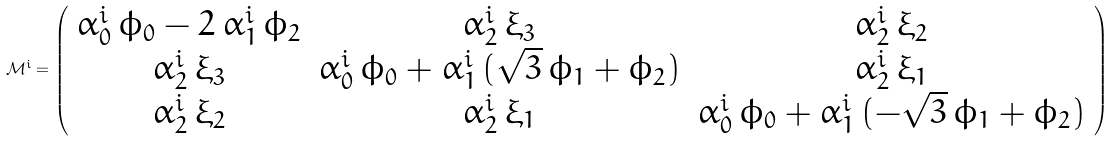Convert formula to latex. <formula><loc_0><loc_0><loc_500><loc_500>\mathcal { M } ^ { i } = \left ( \begin{array} { c c c } \alpha ^ { i } _ { 0 } \, \phi _ { 0 } - 2 \, \alpha ^ { i } _ { 1 } \, \phi _ { 2 } & \alpha ^ { i } _ { 2 } \, \xi _ { 3 } & \alpha ^ { i } _ { 2 } \, \xi _ { 2 } \\ \alpha ^ { i } _ { 2 } \, \xi _ { 3 } & \alpha ^ { i } _ { 0 } \, \phi _ { 0 } + \alpha ^ { i } _ { 1 } \, ( \sqrt { 3 } \, \phi _ { 1 } + \phi _ { 2 } ) & \alpha ^ { i } _ { 2 } \, \xi _ { 1 } \\ \alpha ^ { i } _ { 2 } \, \xi _ { 2 } & \alpha ^ { i } _ { 2 } \, \xi _ { 1 } & \alpha ^ { i } _ { 0 } \, \phi _ { 0 } + \alpha ^ { i } _ { 1 } \, ( - \sqrt { 3 } \, \phi _ { 1 } + \phi _ { 2 } ) \end{array} \right )</formula> 